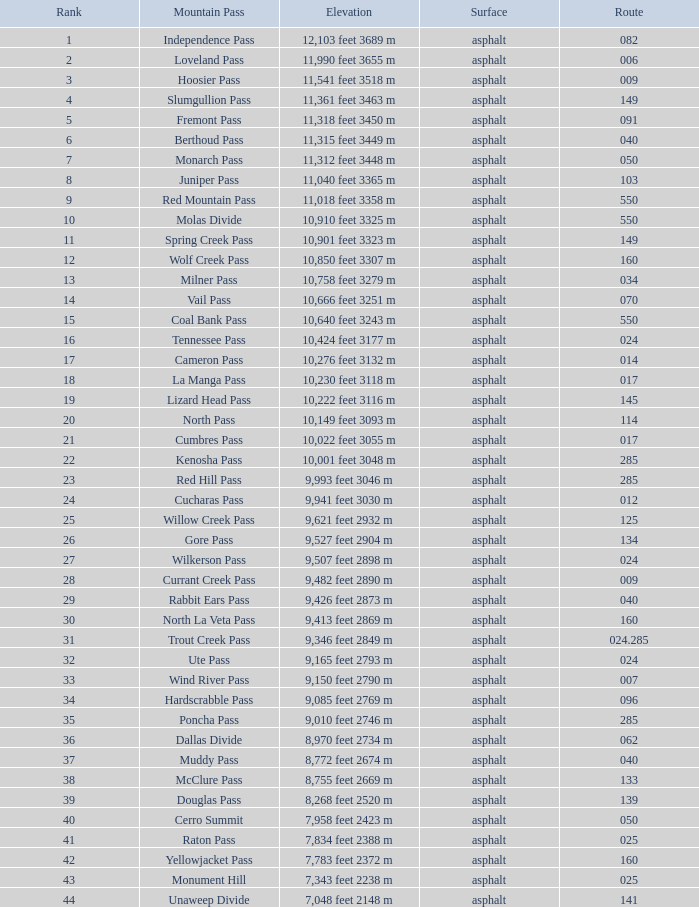What Mountain Pass has an Elevation of 10,001 feet 3048 m? Kenosha Pass. 